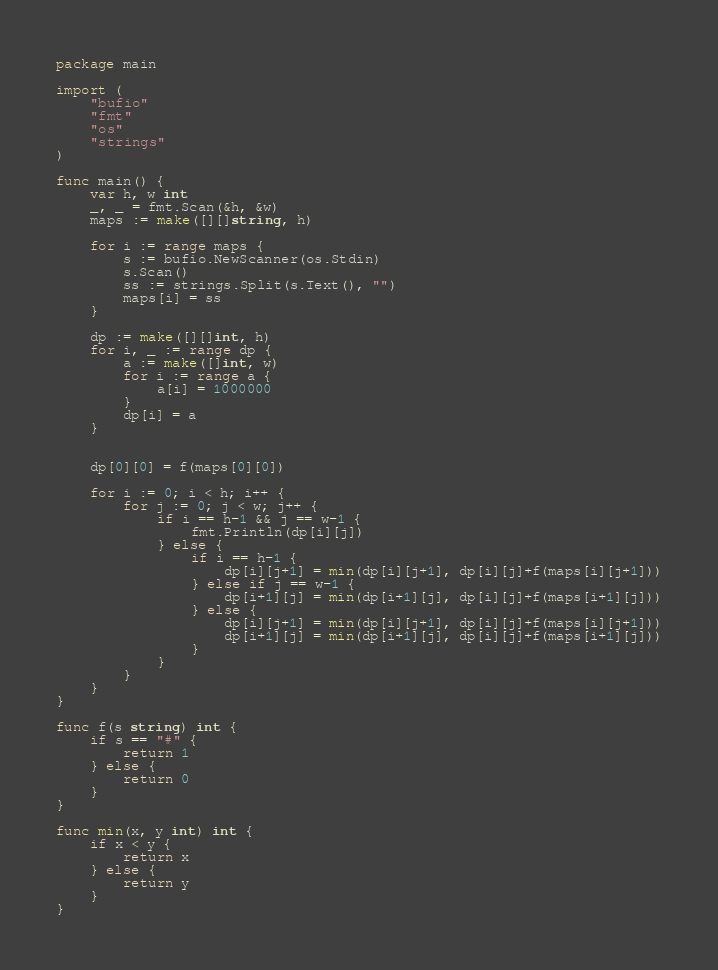<code> <loc_0><loc_0><loc_500><loc_500><_Go_>package main

import (
	"bufio"
	"fmt"
	"os"
	"strings"
)

func main() {
	var h, w int
	_, _ = fmt.Scan(&h, &w)
	maps := make([][]string, h)
	
	for i := range maps {
		s := bufio.NewScanner(os.Stdin)
		s.Scan()
		ss := strings.Split(s.Text(), "")
		maps[i] = ss
	}
	
	dp := make([][]int, h)
	for i, _ := range dp {
		a := make([]int, w)
		for i := range a {
			a[i] = 1000000
		}
		dp[i] = a
	}
	
	
	dp[0][0] = f(maps[0][0])
	
	for i := 0; i < h; i++ {
		for j := 0; j < w; j++ {
			if i == h-1 && j == w-1 {
				fmt.Println(dp[i][j])
			} else {
				if i == h-1 {
					dp[i][j+1] = min(dp[i][j+1], dp[i][j]+f(maps[i][j+1]))
				} else if j == w-1 {
					dp[i+1][j] = min(dp[i+1][j], dp[i][j]+f(maps[i+1][j]))
				} else {
					dp[i][j+1] = min(dp[i][j+1], dp[i][j]+f(maps[i][j+1]))
					dp[i+1][j] = min(dp[i+1][j], dp[i][j]+f(maps[i+1][j]))
				}
			}
		}
	}
}

func f(s string) int {
	if s == "#" {
		return 1
	} else {
		return 0
	}
}

func min(x, y int) int {
	if x < y {
		return x
	} else {
		return y
	}
}
</code> 